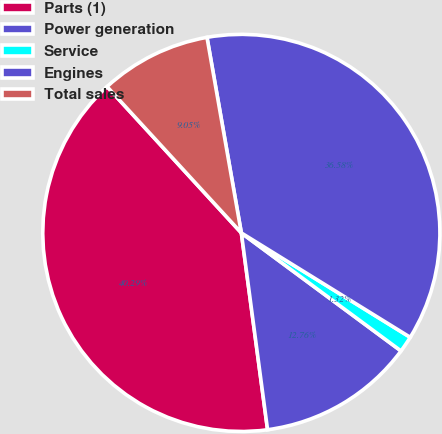Convert chart. <chart><loc_0><loc_0><loc_500><loc_500><pie_chart><fcel>Parts (1)<fcel>Power generation<fcel>Service<fcel>Engines<fcel>Total sales<nl><fcel>40.29%<fcel>12.76%<fcel>1.32%<fcel>36.58%<fcel>9.05%<nl></chart> 